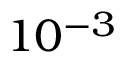Convert formula to latex. <formula><loc_0><loc_0><loc_500><loc_500>1 0 ^ { - 3 }</formula> 